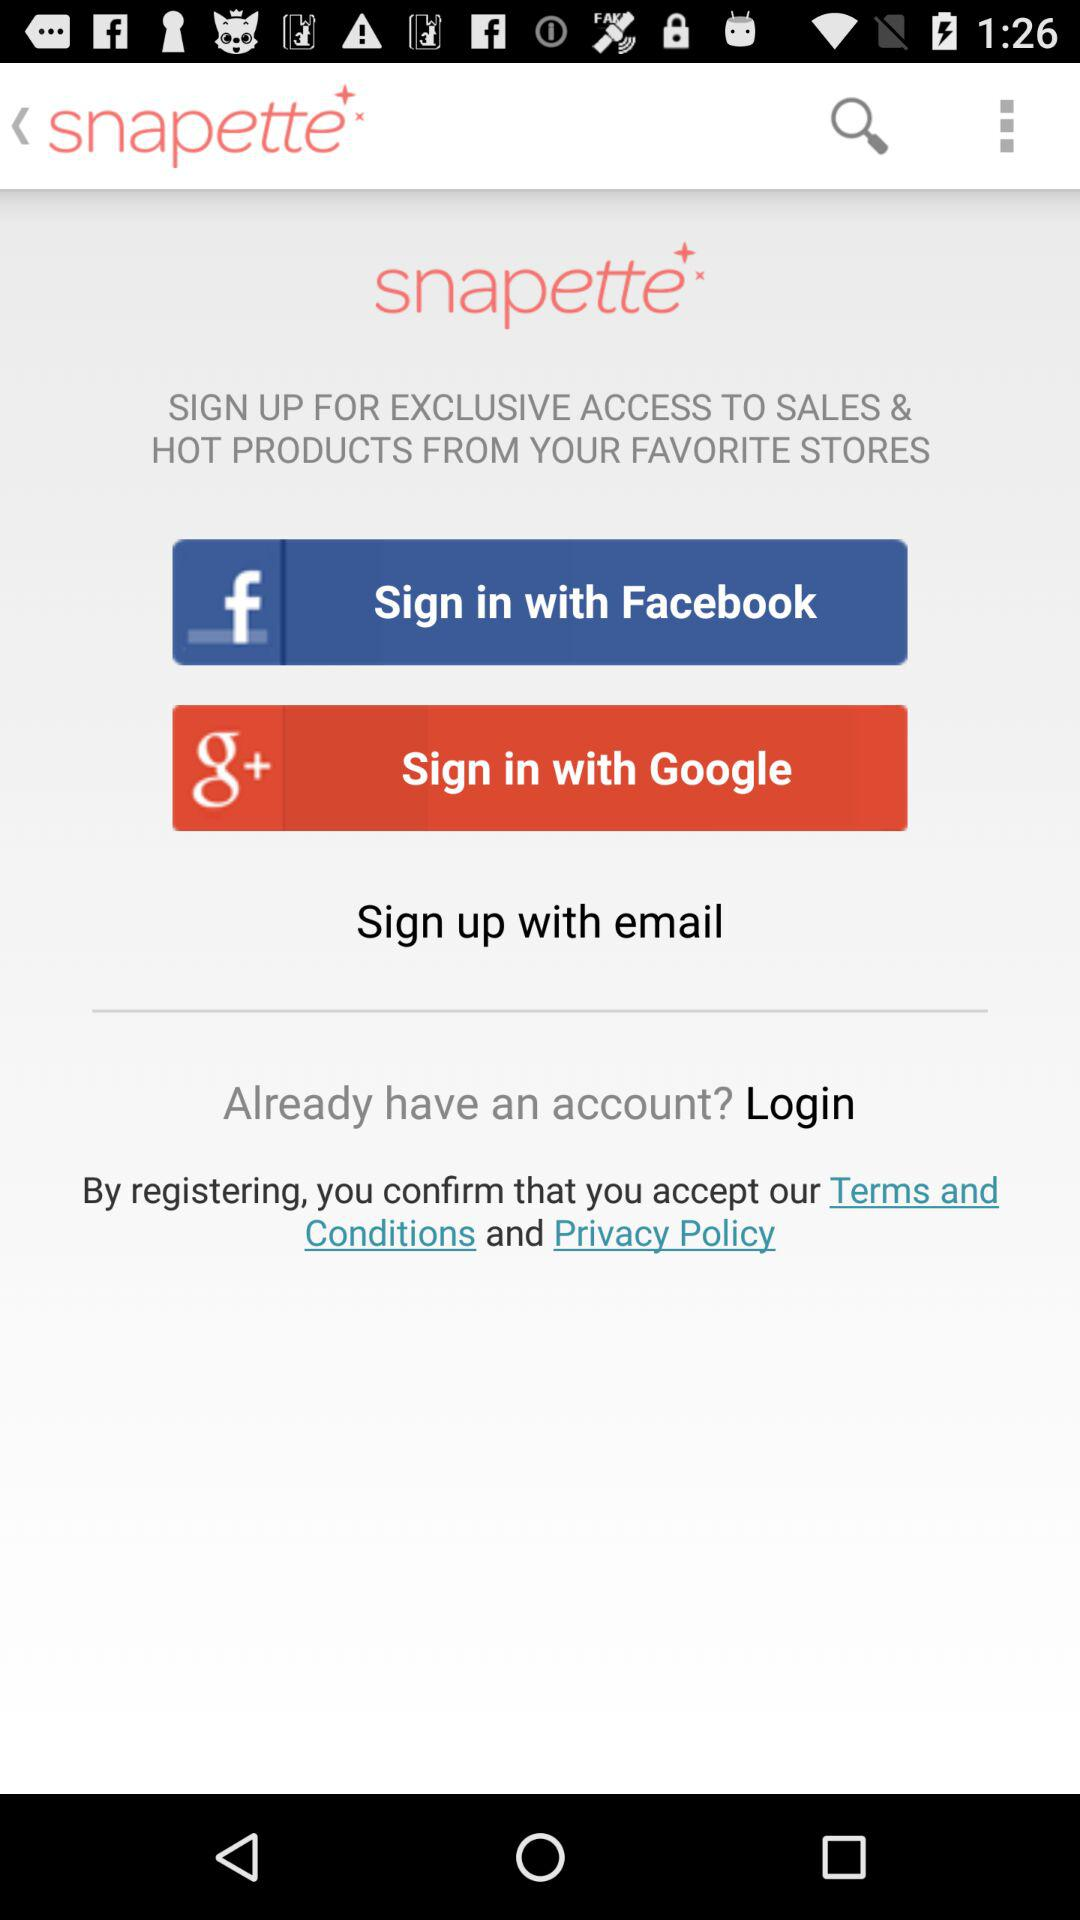What is the application name? The application name is "snapette". 